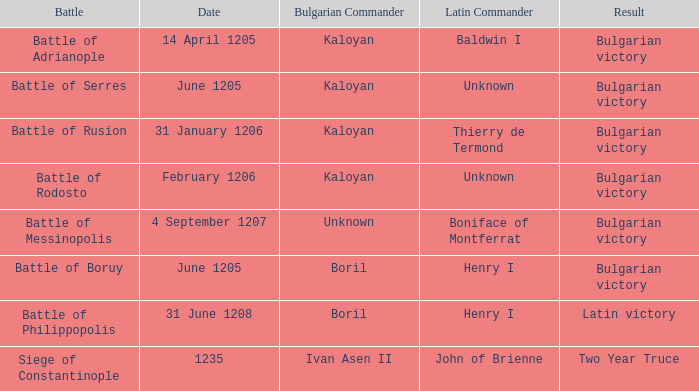What is the Battle with Bulgarian Commander Ivan Asen II? Siege of Constantinople. 